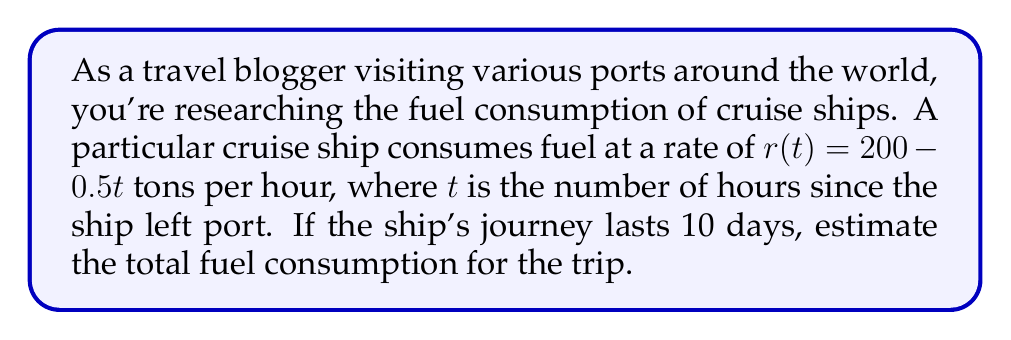Could you help me with this problem? To solve this problem, we need to follow these steps:

1) First, we need to convert the journey time from days to hours:
   10 days = 10 * 24 = 240 hours

2) The fuel consumption rate is given by the function $r(t) = 200 - 0.5t$ tons per hour.

3) To find the total fuel consumption, we need to integrate this rate function over the time period:

   $$\text{Total Fuel} = \int_0^{240} (200 - 0.5t) dt$$

4) Let's solve this integral:

   $$\begin{align}
   \int_0^{240} (200 - 0.5t) dt &= [200t - 0.25t^2]_0^{240} \\
   &= (200 * 240 - 0.25 * 240^2) - (200 * 0 - 0.25 * 0^2) \\
   &= 48000 - 14400 - 0 \\
   &= 33600
   \end{align}$$

5) Therefore, the total fuel consumption for the 10-day trip is 33,600 tons.
Answer: The estimated total fuel consumption for the 10-day cruise ship journey is 33,600 tons. 